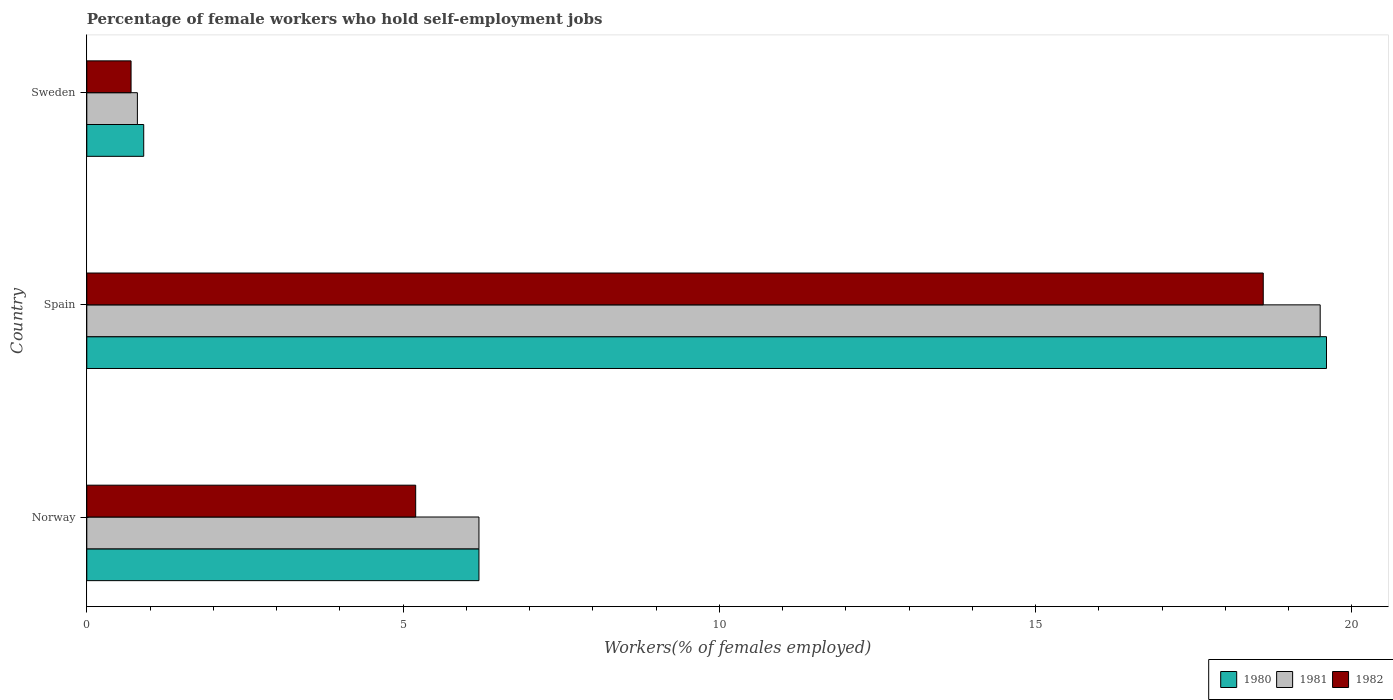How many bars are there on the 3rd tick from the bottom?
Make the answer very short. 3. In how many cases, is the number of bars for a given country not equal to the number of legend labels?
Ensure brevity in your answer.  0. What is the percentage of self-employed female workers in 1982 in Spain?
Your answer should be compact. 18.6. Across all countries, what is the maximum percentage of self-employed female workers in 1981?
Your answer should be very brief. 19.5. Across all countries, what is the minimum percentage of self-employed female workers in 1982?
Your answer should be very brief. 0.7. What is the total percentage of self-employed female workers in 1980 in the graph?
Provide a short and direct response. 26.7. What is the difference between the percentage of self-employed female workers in 1980 in Norway and that in Sweden?
Your answer should be compact. 5.3. What is the difference between the percentage of self-employed female workers in 1981 in Norway and the percentage of self-employed female workers in 1982 in Sweden?
Ensure brevity in your answer.  5.5. What is the average percentage of self-employed female workers in 1980 per country?
Give a very brief answer. 8.9. What is the difference between the percentage of self-employed female workers in 1981 and percentage of self-employed female workers in 1982 in Spain?
Offer a very short reply. 0.9. In how many countries, is the percentage of self-employed female workers in 1982 greater than 18 %?
Make the answer very short. 1. What is the ratio of the percentage of self-employed female workers in 1980 in Spain to that in Sweden?
Ensure brevity in your answer.  21.78. Is the difference between the percentage of self-employed female workers in 1981 in Norway and Sweden greater than the difference between the percentage of self-employed female workers in 1982 in Norway and Sweden?
Provide a succinct answer. Yes. What is the difference between the highest and the second highest percentage of self-employed female workers in 1981?
Give a very brief answer. 13.3. What is the difference between the highest and the lowest percentage of self-employed female workers in 1982?
Provide a succinct answer. 17.9. Is the sum of the percentage of self-employed female workers in 1980 in Norway and Sweden greater than the maximum percentage of self-employed female workers in 1981 across all countries?
Make the answer very short. No. Are all the bars in the graph horizontal?
Ensure brevity in your answer.  Yes. How many countries are there in the graph?
Keep it short and to the point. 3. What is the difference between two consecutive major ticks on the X-axis?
Provide a succinct answer. 5. Does the graph contain any zero values?
Give a very brief answer. No. How many legend labels are there?
Give a very brief answer. 3. How are the legend labels stacked?
Make the answer very short. Horizontal. What is the title of the graph?
Offer a terse response. Percentage of female workers who hold self-employment jobs. What is the label or title of the X-axis?
Your answer should be very brief. Workers(% of females employed). What is the Workers(% of females employed) of 1980 in Norway?
Offer a terse response. 6.2. What is the Workers(% of females employed) in 1981 in Norway?
Your answer should be compact. 6.2. What is the Workers(% of females employed) of 1982 in Norway?
Keep it short and to the point. 5.2. What is the Workers(% of females employed) in 1980 in Spain?
Your response must be concise. 19.6. What is the Workers(% of females employed) of 1981 in Spain?
Provide a short and direct response. 19.5. What is the Workers(% of females employed) of 1982 in Spain?
Make the answer very short. 18.6. What is the Workers(% of females employed) of 1980 in Sweden?
Your answer should be very brief. 0.9. What is the Workers(% of females employed) in 1981 in Sweden?
Your answer should be very brief. 0.8. What is the Workers(% of females employed) of 1982 in Sweden?
Keep it short and to the point. 0.7. Across all countries, what is the maximum Workers(% of females employed) in 1980?
Your response must be concise. 19.6. Across all countries, what is the maximum Workers(% of females employed) in 1982?
Provide a short and direct response. 18.6. Across all countries, what is the minimum Workers(% of females employed) in 1980?
Offer a very short reply. 0.9. Across all countries, what is the minimum Workers(% of females employed) in 1981?
Make the answer very short. 0.8. Across all countries, what is the minimum Workers(% of females employed) in 1982?
Keep it short and to the point. 0.7. What is the total Workers(% of females employed) of 1980 in the graph?
Keep it short and to the point. 26.7. What is the total Workers(% of females employed) of 1981 in the graph?
Give a very brief answer. 26.5. What is the difference between the Workers(% of females employed) of 1981 in Norway and that in Spain?
Provide a short and direct response. -13.3. What is the difference between the Workers(% of females employed) of 1982 in Norway and that in Spain?
Provide a short and direct response. -13.4. What is the difference between the Workers(% of females employed) in 1981 in Norway and that in Sweden?
Make the answer very short. 5.4. What is the difference between the Workers(% of females employed) in 1982 in Norway and that in Sweden?
Your response must be concise. 4.5. What is the difference between the Workers(% of females employed) in 1980 in Norway and the Workers(% of females employed) in 1982 in Spain?
Give a very brief answer. -12.4. What is the difference between the Workers(% of females employed) of 1981 in Spain and the Workers(% of females employed) of 1982 in Sweden?
Make the answer very short. 18.8. What is the average Workers(% of females employed) of 1980 per country?
Your response must be concise. 8.9. What is the average Workers(% of females employed) in 1981 per country?
Provide a short and direct response. 8.83. What is the average Workers(% of females employed) in 1982 per country?
Ensure brevity in your answer.  8.17. What is the difference between the Workers(% of females employed) of 1980 and Workers(% of females employed) of 1981 in Norway?
Your response must be concise. 0. What is the difference between the Workers(% of females employed) in 1981 and Workers(% of females employed) in 1982 in Norway?
Ensure brevity in your answer.  1. What is the difference between the Workers(% of females employed) in 1980 and Workers(% of females employed) in 1981 in Spain?
Provide a short and direct response. 0.1. What is the difference between the Workers(% of females employed) of 1981 and Workers(% of females employed) of 1982 in Spain?
Provide a short and direct response. 0.9. What is the difference between the Workers(% of females employed) in 1981 and Workers(% of females employed) in 1982 in Sweden?
Your answer should be very brief. 0.1. What is the ratio of the Workers(% of females employed) of 1980 in Norway to that in Spain?
Provide a short and direct response. 0.32. What is the ratio of the Workers(% of females employed) of 1981 in Norway to that in Spain?
Make the answer very short. 0.32. What is the ratio of the Workers(% of females employed) of 1982 in Norway to that in Spain?
Provide a succinct answer. 0.28. What is the ratio of the Workers(% of females employed) in 1980 in Norway to that in Sweden?
Give a very brief answer. 6.89. What is the ratio of the Workers(% of females employed) in 1981 in Norway to that in Sweden?
Offer a terse response. 7.75. What is the ratio of the Workers(% of females employed) in 1982 in Norway to that in Sweden?
Your answer should be compact. 7.43. What is the ratio of the Workers(% of females employed) in 1980 in Spain to that in Sweden?
Ensure brevity in your answer.  21.78. What is the ratio of the Workers(% of females employed) of 1981 in Spain to that in Sweden?
Your answer should be compact. 24.38. What is the ratio of the Workers(% of females employed) of 1982 in Spain to that in Sweden?
Your response must be concise. 26.57. What is the difference between the highest and the second highest Workers(% of females employed) in 1980?
Provide a short and direct response. 13.4. What is the difference between the highest and the lowest Workers(% of females employed) in 1980?
Ensure brevity in your answer.  18.7. What is the difference between the highest and the lowest Workers(% of females employed) of 1981?
Keep it short and to the point. 18.7. What is the difference between the highest and the lowest Workers(% of females employed) of 1982?
Your answer should be compact. 17.9. 